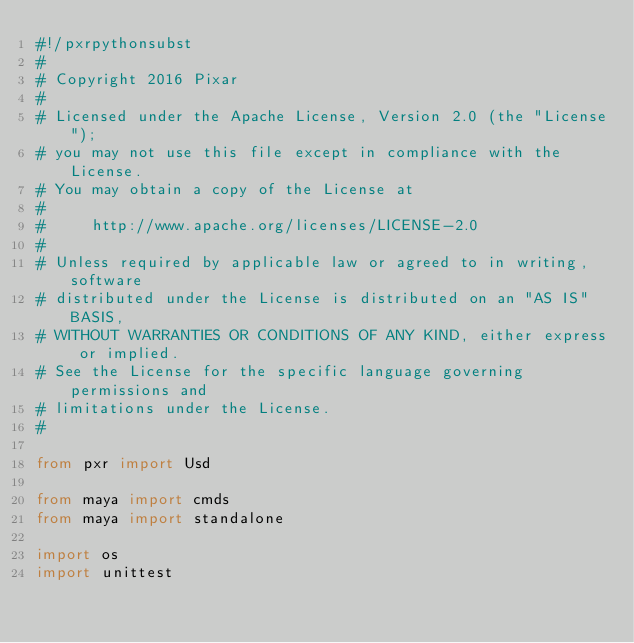Convert code to text. <code><loc_0><loc_0><loc_500><loc_500><_Python_>#!/pxrpythonsubst
#
# Copyright 2016 Pixar
#
# Licensed under the Apache License, Version 2.0 (the "License");
# you may not use this file except in compliance with the License.
# You may obtain a copy of the License at
#
#     http://www.apache.org/licenses/LICENSE-2.0
#
# Unless required by applicable law or agreed to in writing, software
# distributed under the License is distributed on an "AS IS" BASIS,
# WITHOUT WARRANTIES OR CONDITIONS OF ANY KIND, either express or implied.
# See the License for the specific language governing permissions and
# limitations under the License.
#

from pxr import Usd

from maya import cmds
from maya import standalone

import os
import unittest

</code> 